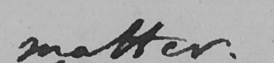Can you tell me what this handwritten text says? matter . 